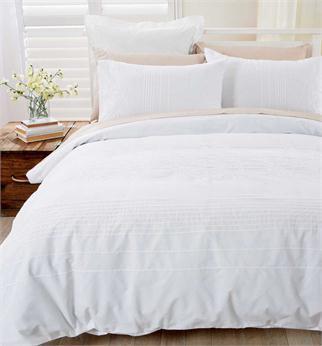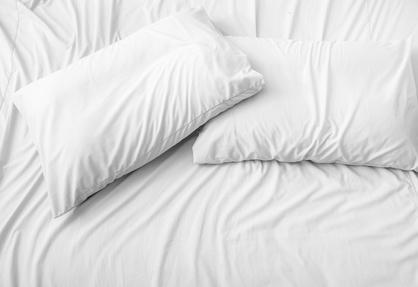The first image is the image on the left, the second image is the image on the right. Assess this claim about the two images: "One of the images contains exactly two white pillows.". Correct or not? Answer yes or no. Yes. 